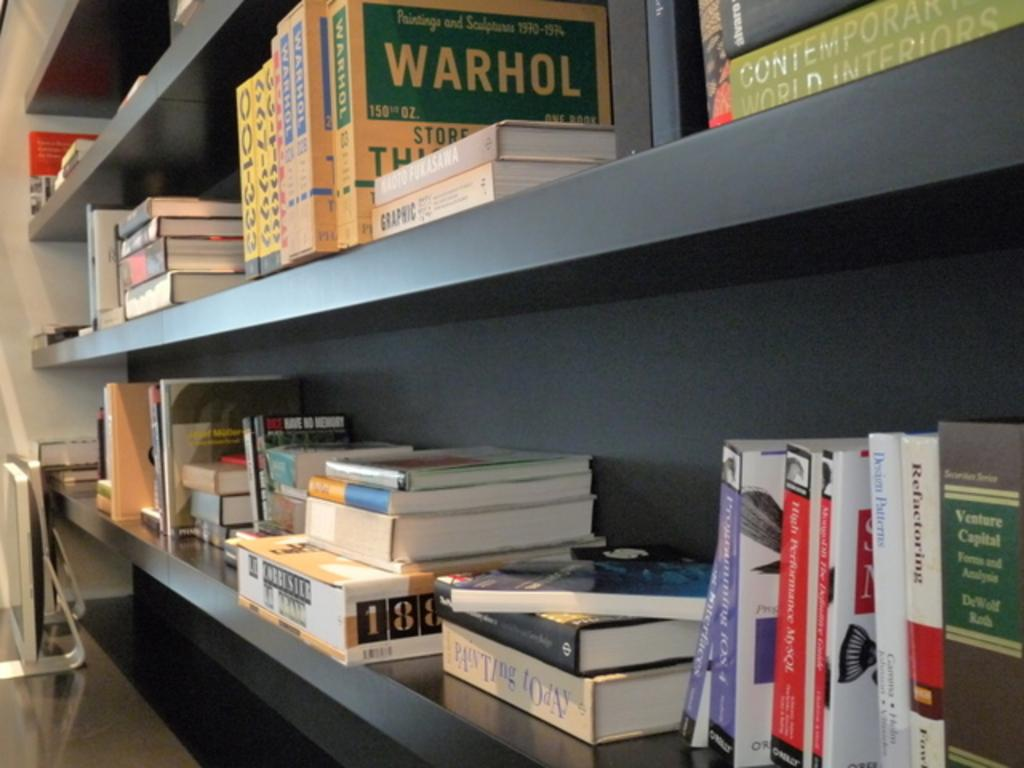<image>
Render a clear and concise summary of the photo. many books and one that has warhol written on it 